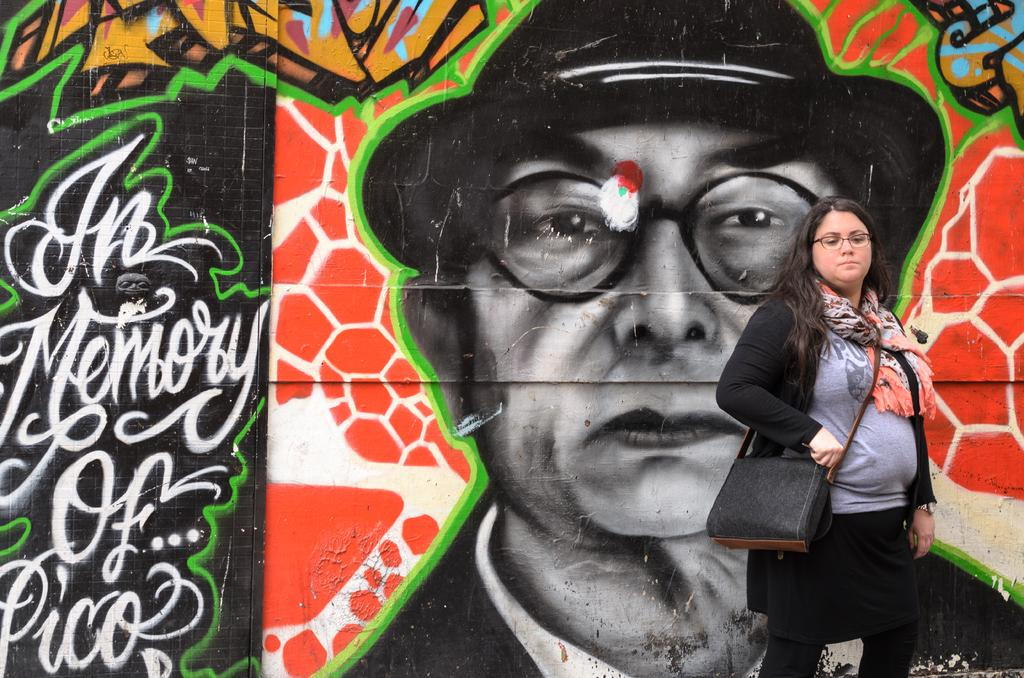Who or what is present in the image? There is a person in the image. What is the person wearing? The person is wearing clothes. Where is the person standing in the image? The person is standing in front of a wall. What can be seen on the wall? The wall contains some art. Can you hear the person whistling in the image? There is no indication of sound or whistling in the image; it only provides visual information. 